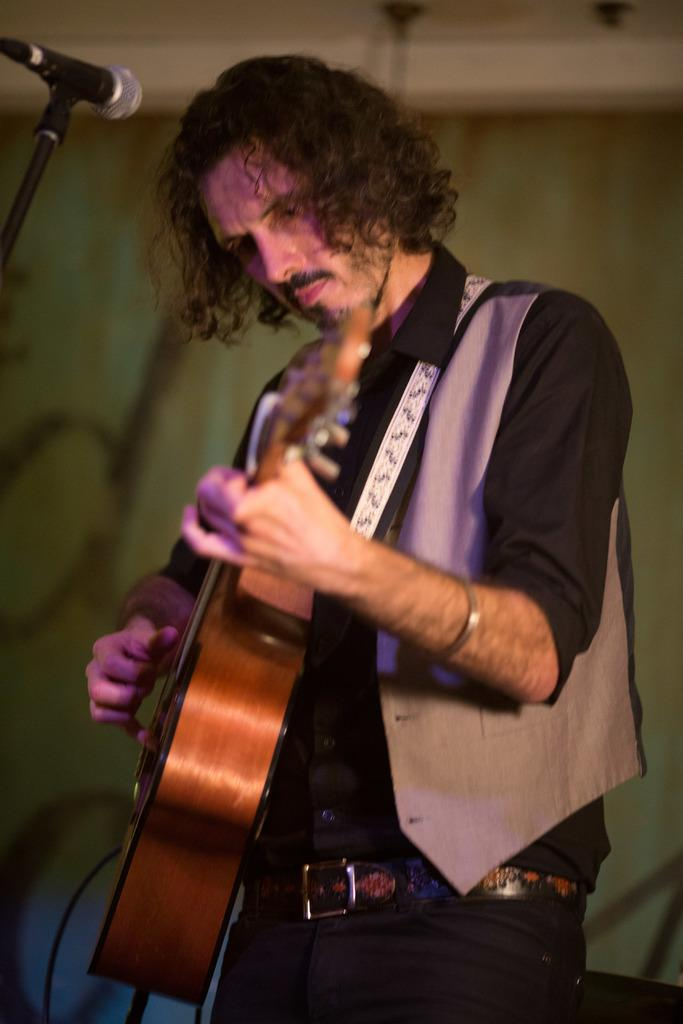What is the main subject of the image? The main subject of the image is a man. What is the man doing in the image? The man is standing and playing a guitar. Can you describe anything in the background of the image? Yes, there is a microphone in the background of the image. What type of eggs can be seen in the image? There are no eggs present in the image. How does the copper in the image reflect the sunlight? There is no copper present in the image. 